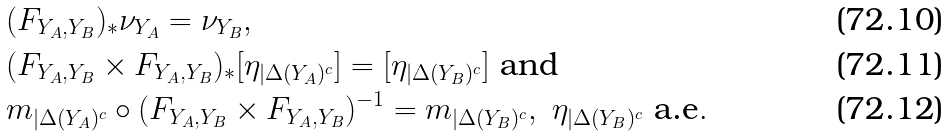<formula> <loc_0><loc_0><loc_500><loc_500>& ( F _ { Y _ { A } , Y _ { B } } ) _ { * } \nu _ { Y _ { A } } = \nu _ { Y _ { B } } , \\ & ( F _ { Y _ { A } , Y _ { B } } \times F _ { Y _ { A } , Y _ { B } } ) _ { * } [ \eta _ { | \Delta ( Y _ { A } ) ^ { c } } ] = [ \eta _ { | \Delta ( Y _ { B } ) ^ { c } } ] \text { and} \\ & m _ { | \Delta ( Y _ { A } ) ^ { c } } \circ ( F _ { Y _ { A } , Y _ { B } } \times F _ { Y _ { A } , Y _ { B } } ) ^ { - 1 } = m _ { | \Delta ( Y _ { B } ) ^ { c } } , { \text { } } \eta _ { | \Delta ( Y _ { B } ) ^ { c } } { \text { a.e} } .</formula> 